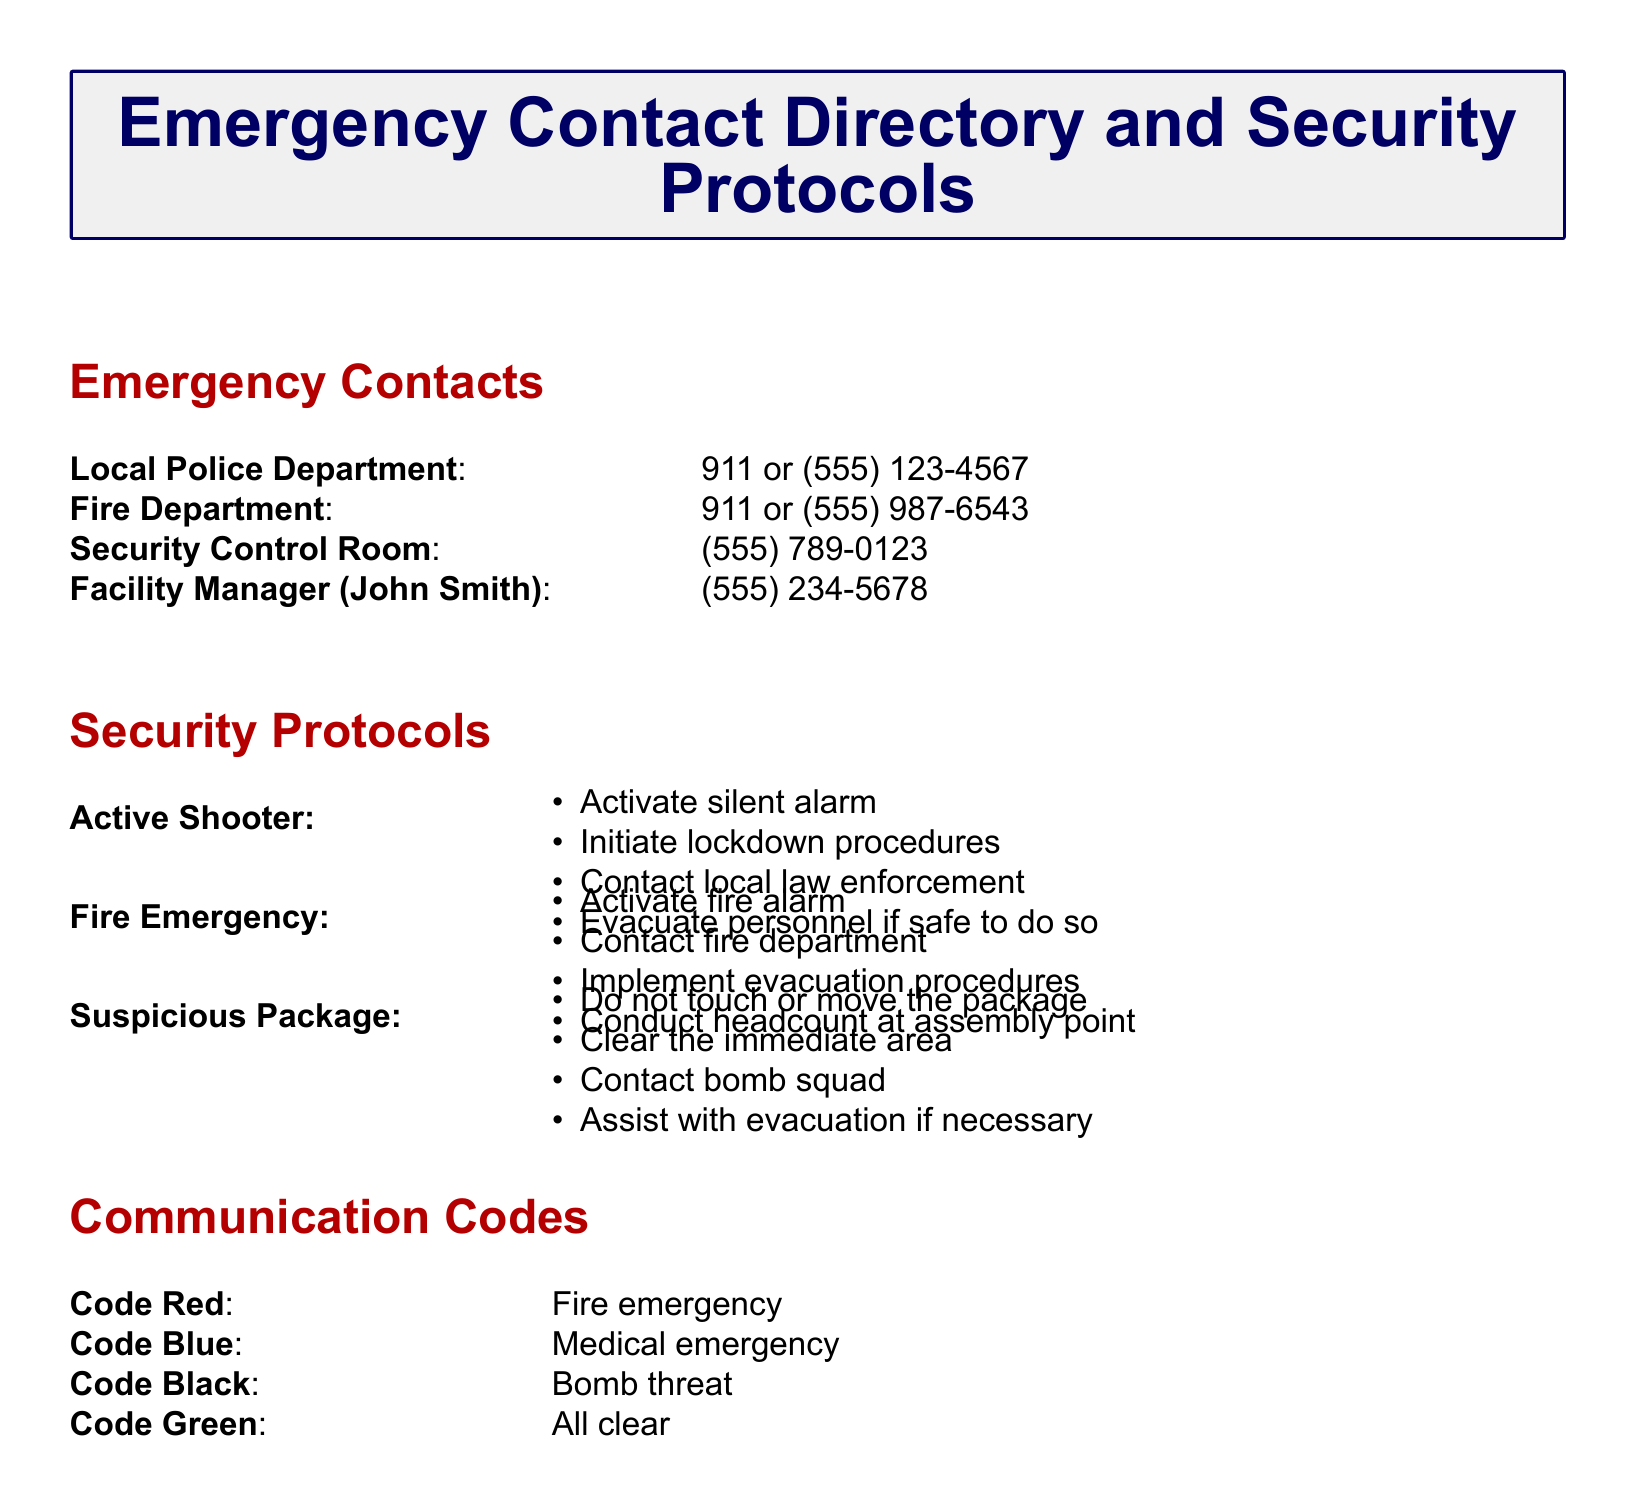What is the contact number for the Fire Department? The Fire Department's contact number is specified in the document for emergencies.
Answer: 911 or (555) 987-6543 What should you do in case of an Active Shooter scenario? The document lists specific actions to take during an Active Shooter situation.
Answer: Activate silent alarm, initiate lockdown, contact law enforcement, evacuate personnel What code is used for a bomb threat? The document includes communication codes for various emergencies, including code for bomb threats.
Answer: Code Black Who is the Facility Manager? The document provides the name of the person responsible for facility management.
Answer: John Smith What is the first action to take during a Fire Emergency? According to the protocol listed, the first action in a Fire Emergency is crucial.
Answer: Activate fire alarm How many steps are listed for dealing with a Suspicious Package? The protocol section outlines actions to take for a Suspicious Package, which can be counted.
Answer: Four steps What is the emergency contact number for the Security Control Room? The document provides specific numbers for emergency contacts.
Answer: (555) 789-0123 What protocol should be followed during a Code Red situation? The document details what actions are necessary during a fire emergency identified as Code Red.
Answer: Fire emergency Which emergency service is contacted in case of an Active Shooter? The document specifies which services to contact in case of an Active Shooter.
Answer: Local law enforcement 